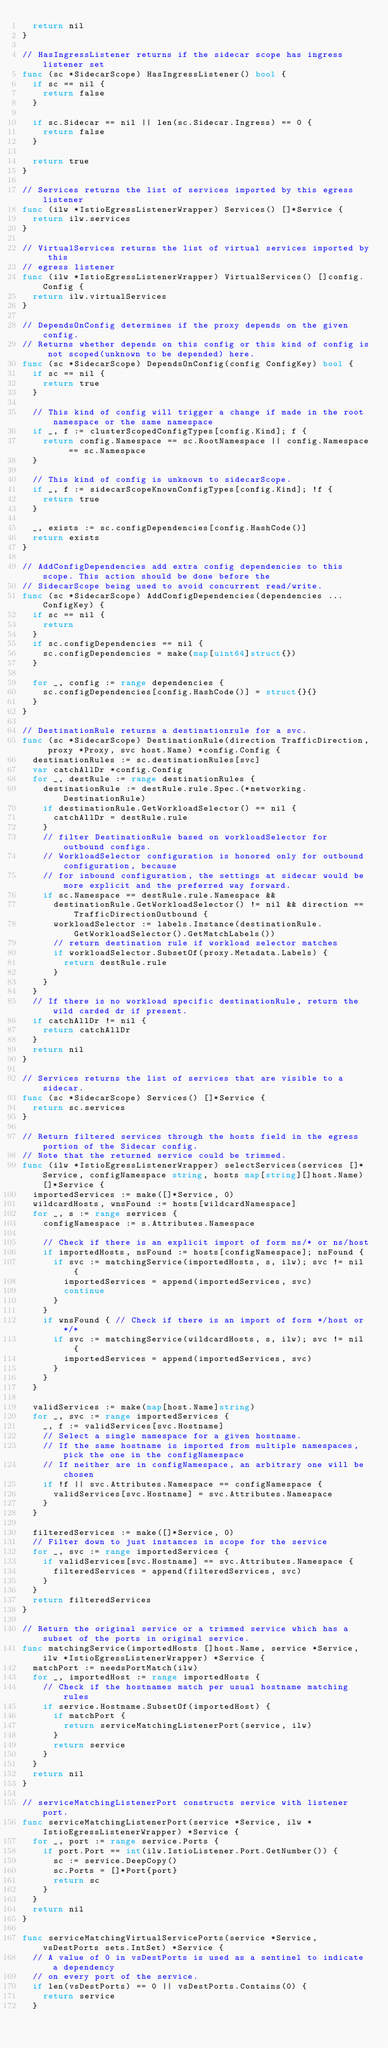Convert code to text. <code><loc_0><loc_0><loc_500><loc_500><_Go_>	return nil
}

// HasIngressListener returns if the sidecar scope has ingress listener set
func (sc *SidecarScope) HasIngressListener() bool {
	if sc == nil {
		return false
	}

	if sc.Sidecar == nil || len(sc.Sidecar.Ingress) == 0 {
		return false
	}

	return true
}

// Services returns the list of services imported by this egress listener
func (ilw *IstioEgressListenerWrapper) Services() []*Service {
	return ilw.services
}

// VirtualServices returns the list of virtual services imported by this
// egress listener
func (ilw *IstioEgressListenerWrapper) VirtualServices() []config.Config {
	return ilw.virtualServices
}

// DependsOnConfig determines if the proxy depends on the given config.
// Returns whether depends on this config or this kind of config is not scoped(unknown to be depended) here.
func (sc *SidecarScope) DependsOnConfig(config ConfigKey) bool {
	if sc == nil {
		return true
	}

	// This kind of config will trigger a change if made in the root namespace or the same namespace
	if _, f := clusterScopedConfigTypes[config.Kind]; f {
		return config.Namespace == sc.RootNamespace || config.Namespace == sc.Namespace
	}

	// This kind of config is unknown to sidecarScope.
	if _, f := sidecarScopeKnownConfigTypes[config.Kind]; !f {
		return true
	}

	_, exists := sc.configDependencies[config.HashCode()]
	return exists
}

// AddConfigDependencies add extra config dependencies to this scope. This action should be done before the
// SidecarScope being used to avoid concurrent read/write.
func (sc *SidecarScope) AddConfigDependencies(dependencies ...ConfigKey) {
	if sc == nil {
		return
	}
	if sc.configDependencies == nil {
		sc.configDependencies = make(map[uint64]struct{})
	}

	for _, config := range dependencies {
		sc.configDependencies[config.HashCode()] = struct{}{}
	}
}

// DestinationRule returns a destinationrule for a svc.
func (sc *SidecarScope) DestinationRule(direction TrafficDirection, proxy *Proxy, svc host.Name) *config.Config {
	destinationRules := sc.destinationRules[svc]
	var catchAllDr *config.Config
	for _, destRule := range destinationRules {
		destinationRule := destRule.rule.Spec.(*networking.DestinationRule)
		if destinationRule.GetWorkloadSelector() == nil {
			catchAllDr = destRule.rule
		}
		// filter DestinationRule based on workloadSelector for outbound configs.
		// WorkloadSelector configuration is honored only for outbound configuration, because
		// for inbound configuration, the settings at sidecar would be more explicit and the preferred way forward.
		if sc.Namespace == destRule.rule.Namespace &&
			destinationRule.GetWorkloadSelector() != nil && direction == TrafficDirectionOutbound {
			workloadSelector := labels.Instance(destinationRule.GetWorkloadSelector().GetMatchLabels())
			// return destination rule if workload selector matches
			if workloadSelector.SubsetOf(proxy.Metadata.Labels) {
				return destRule.rule
			}
		}
	}
	// If there is no workload specific destinationRule, return the wild carded dr if present.
	if catchAllDr != nil {
		return catchAllDr
	}
	return nil
}

// Services returns the list of services that are visible to a sidecar.
func (sc *SidecarScope) Services() []*Service {
	return sc.services
}

// Return filtered services through the hosts field in the egress portion of the Sidecar config.
// Note that the returned service could be trimmed.
func (ilw *IstioEgressListenerWrapper) selectServices(services []*Service, configNamespace string, hosts map[string][]host.Name) []*Service {
	importedServices := make([]*Service, 0)
	wildcardHosts, wnsFound := hosts[wildcardNamespace]
	for _, s := range services {
		configNamespace := s.Attributes.Namespace

		// Check if there is an explicit import of form ns/* or ns/host
		if importedHosts, nsFound := hosts[configNamespace]; nsFound {
			if svc := matchingService(importedHosts, s, ilw); svc != nil {
				importedServices = append(importedServices, svc)
				continue
			}
		}
		if wnsFound { // Check if there is an import of form */host or */*
			if svc := matchingService(wildcardHosts, s, ilw); svc != nil {
				importedServices = append(importedServices, svc)
			}
		}
	}

	validServices := make(map[host.Name]string)
	for _, svc := range importedServices {
		_, f := validServices[svc.Hostname]
		// Select a single namespace for a given hostname.
		// If the same hostname is imported from multiple namespaces, pick the one in the configNamespace
		// If neither are in configNamespace, an arbitrary one will be chosen
		if !f || svc.Attributes.Namespace == configNamespace {
			validServices[svc.Hostname] = svc.Attributes.Namespace
		}
	}

	filteredServices := make([]*Service, 0)
	// Filter down to just instances in scope for the service
	for _, svc := range importedServices {
		if validServices[svc.Hostname] == svc.Attributes.Namespace {
			filteredServices = append(filteredServices, svc)
		}
	}
	return filteredServices
}

// Return the original service or a trimmed service which has a subset of the ports in original service.
func matchingService(importedHosts []host.Name, service *Service, ilw *IstioEgressListenerWrapper) *Service {
	matchPort := needsPortMatch(ilw)
	for _, importedHost := range importedHosts {
		// Check if the hostnames match per usual hostname matching rules
		if service.Hostname.SubsetOf(importedHost) {
			if matchPort {
				return serviceMatchingListenerPort(service, ilw)
			}
			return service
		}
	}
	return nil
}

// serviceMatchingListenerPort constructs service with listener port.
func serviceMatchingListenerPort(service *Service, ilw *IstioEgressListenerWrapper) *Service {
	for _, port := range service.Ports {
		if port.Port == int(ilw.IstioListener.Port.GetNumber()) {
			sc := service.DeepCopy()
			sc.Ports = []*Port{port}
			return sc
		}
	}
	return nil
}

func serviceMatchingVirtualServicePorts(service *Service, vsDestPorts sets.IntSet) *Service {
	// A value of 0 in vsDestPorts is used as a sentinel to indicate a dependency
	// on every port of the service.
	if len(vsDestPorts) == 0 || vsDestPorts.Contains(0) {
		return service
	}
</code> 